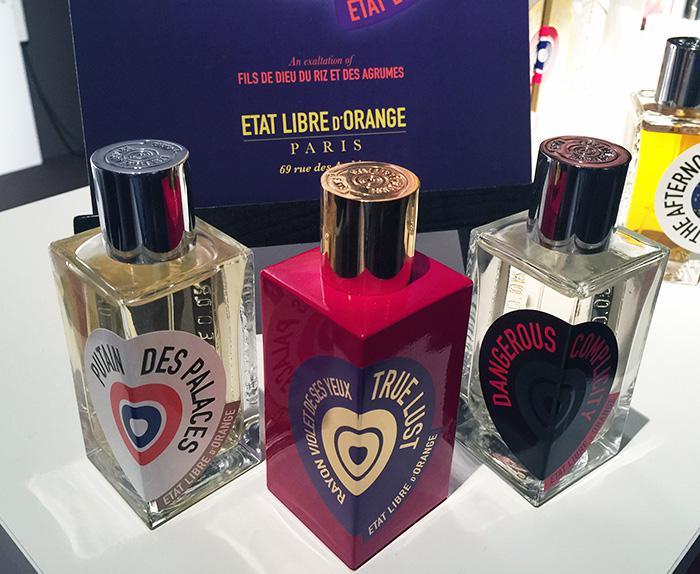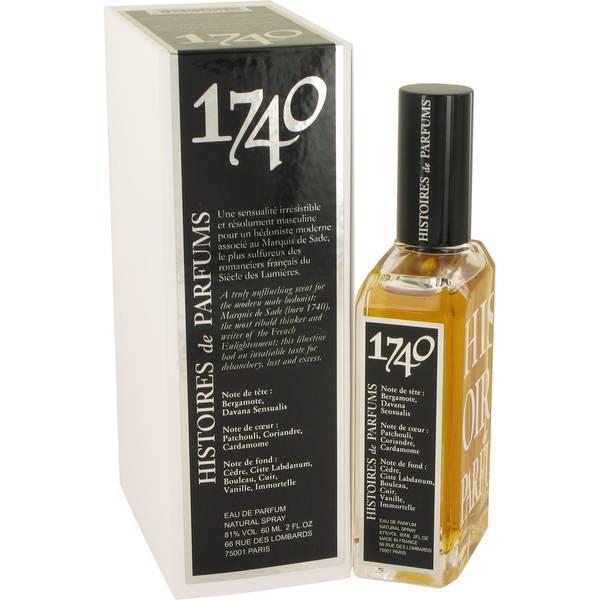The first image is the image on the left, the second image is the image on the right. Considering the images on both sides, is "One of the images shows a single bottle of perfume standing next to its package." valid? Answer yes or no. Yes. The first image is the image on the left, the second image is the image on the right. For the images displayed, is the sentence "One image shows a single squarish bottle to the right of its upright case." factually correct? Answer yes or no. Yes. 